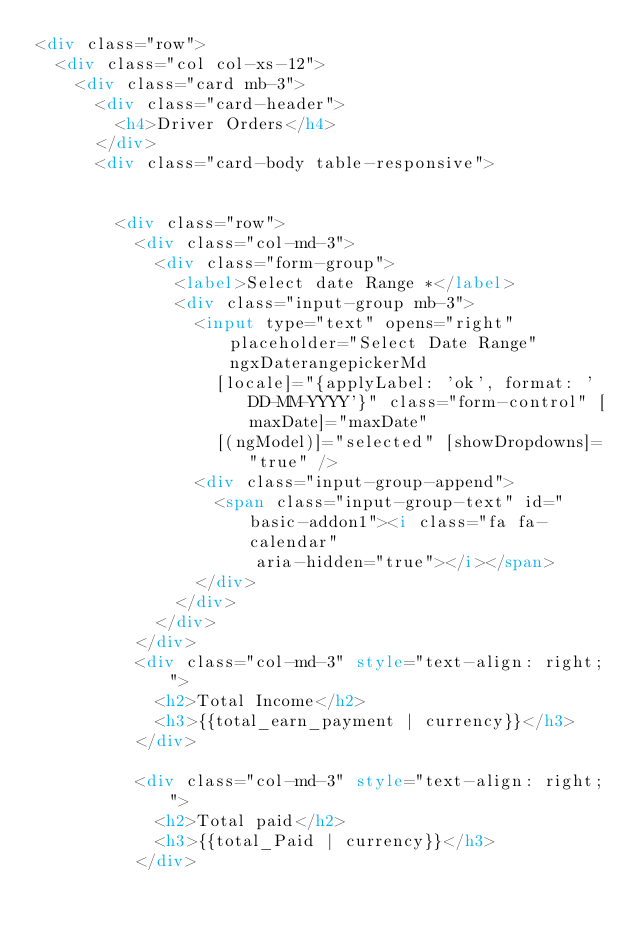<code> <loc_0><loc_0><loc_500><loc_500><_HTML_><div class="row">
  <div class="col col-xs-12">
    <div class="card mb-3">
      <div class="card-header">
        <h4>Driver Orders</h4>
      </div>
      <div class="card-body table-responsive">


        <div class="row">
          <div class="col-md-3">
            <div class="form-group">
              <label>Select date Range *</label>
              <div class="input-group mb-3">
                <input type="text" opens="right" placeholder="Select Date Range" ngxDaterangepickerMd
                  [locale]="{applyLabel: 'ok', format: 'DD-MM-YYYY'}" class="form-control" [maxDate]="maxDate"
                  [(ngModel)]="selected" [showDropdowns]="true" />
                <div class="input-group-append">
                  <span class="input-group-text" id="basic-addon1"><i class="fa fa-calendar"
                      aria-hidden="true"></i></span>
                </div>
              </div>
            </div>
          </div>
          <div class="col-md-3" style="text-align: right;">
            <h2>Total Income</h2>
            <h3>{{total_earn_payment | currency}}</h3>
          </div>

          <div class="col-md-3" style="text-align: right;">
            <h2>Total paid</h2>
            <h3>{{total_Paid | currency}}</h3>
          </div>
</code> 